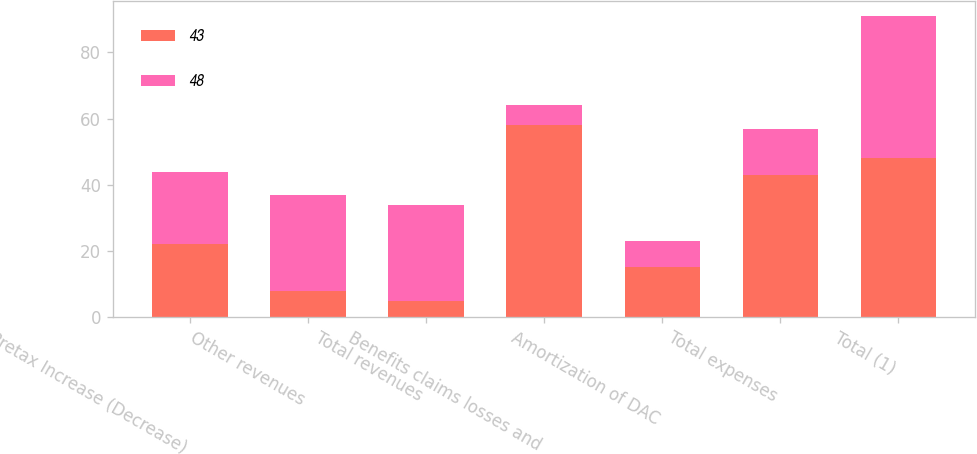Convert chart. <chart><loc_0><loc_0><loc_500><loc_500><stacked_bar_chart><ecel><fcel>Pretax Increase (Decrease)<fcel>Other revenues<fcel>Total revenues<fcel>Benefits claims losses and<fcel>Amortization of DAC<fcel>Total expenses<fcel>Total (1)<nl><fcel>43<fcel>22<fcel>8<fcel>5<fcel>58<fcel>15<fcel>43<fcel>48<nl><fcel>48<fcel>22<fcel>29<fcel>29<fcel>6<fcel>8<fcel>14<fcel>43<nl></chart> 